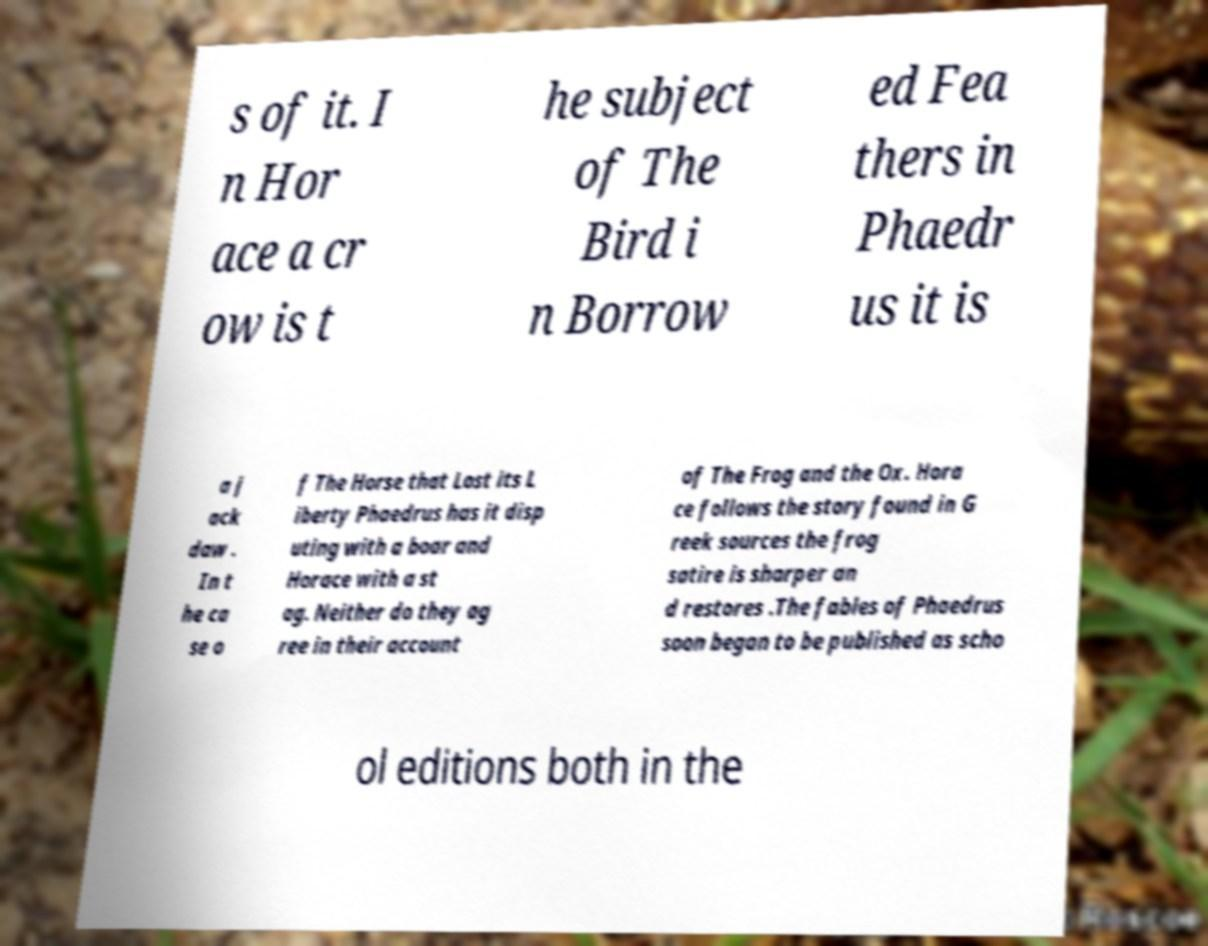Can you accurately transcribe the text from the provided image for me? s of it. I n Hor ace a cr ow is t he subject of The Bird i n Borrow ed Fea thers in Phaedr us it is a j ack daw . In t he ca se o f The Horse that Lost its L iberty Phaedrus has it disp uting with a boar and Horace with a st ag. Neither do they ag ree in their account of The Frog and the Ox. Hora ce follows the story found in G reek sources the frog satire is sharper an d restores .The fables of Phaedrus soon began to be published as scho ol editions both in the 